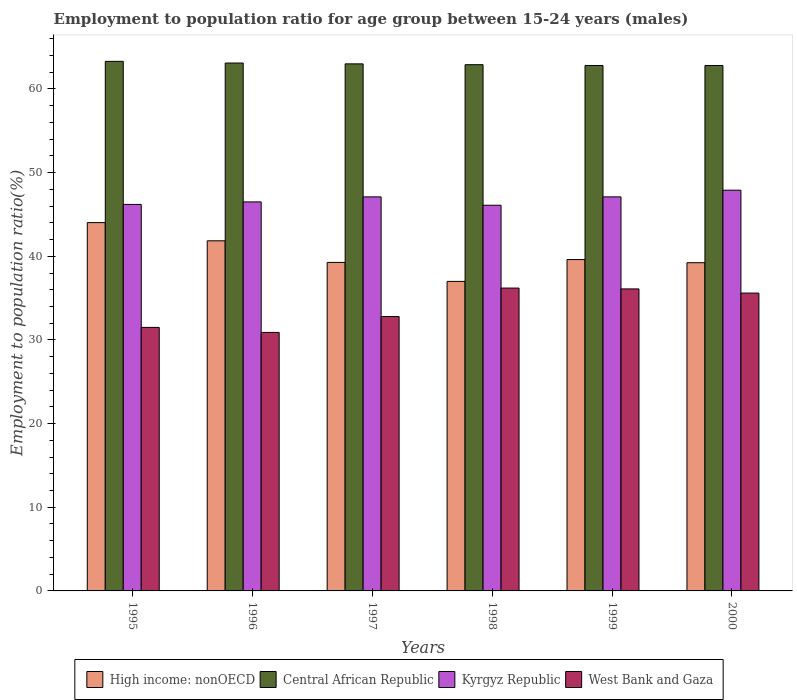Are the number of bars per tick equal to the number of legend labels?
Provide a succinct answer. Yes. What is the employment to population ratio in Central African Republic in 1996?
Keep it short and to the point. 63.1. Across all years, what is the maximum employment to population ratio in High income: nonOECD?
Make the answer very short. 44.03. Across all years, what is the minimum employment to population ratio in West Bank and Gaza?
Provide a succinct answer. 30.9. What is the total employment to population ratio in High income: nonOECD in the graph?
Make the answer very short. 240.98. What is the difference between the employment to population ratio in Kyrgyz Republic in 1995 and that in 1999?
Offer a terse response. -0.9. What is the difference between the employment to population ratio in Central African Republic in 2000 and the employment to population ratio in Kyrgyz Republic in 1995?
Make the answer very short. 16.6. What is the average employment to population ratio in West Bank and Gaza per year?
Your response must be concise. 33.85. In the year 1995, what is the difference between the employment to population ratio in High income: nonOECD and employment to population ratio in Central African Republic?
Ensure brevity in your answer.  -19.27. In how many years, is the employment to population ratio in Kyrgyz Republic greater than 38 %?
Keep it short and to the point. 6. What is the ratio of the employment to population ratio in Kyrgyz Republic in 1999 to that in 2000?
Provide a succinct answer. 0.98. Is the difference between the employment to population ratio in High income: nonOECD in 1996 and 2000 greater than the difference between the employment to population ratio in Central African Republic in 1996 and 2000?
Your response must be concise. Yes. What is the difference between the highest and the second highest employment to population ratio in Kyrgyz Republic?
Keep it short and to the point. 0.8. In how many years, is the employment to population ratio in West Bank and Gaza greater than the average employment to population ratio in West Bank and Gaza taken over all years?
Your answer should be compact. 3. What does the 1st bar from the left in 1996 represents?
Offer a terse response. High income: nonOECD. What does the 2nd bar from the right in 1998 represents?
Offer a terse response. Kyrgyz Republic. How many bars are there?
Your answer should be compact. 24. What is the difference between two consecutive major ticks on the Y-axis?
Keep it short and to the point. 10. Are the values on the major ticks of Y-axis written in scientific E-notation?
Offer a terse response. No. Does the graph contain any zero values?
Your response must be concise. No. Does the graph contain grids?
Keep it short and to the point. No. What is the title of the graph?
Give a very brief answer. Employment to population ratio for age group between 15-24 years (males). What is the label or title of the X-axis?
Make the answer very short. Years. What is the label or title of the Y-axis?
Offer a very short reply. Employment to population ratio(%). What is the Employment to population ratio(%) in High income: nonOECD in 1995?
Your answer should be compact. 44.03. What is the Employment to population ratio(%) of Central African Republic in 1995?
Offer a terse response. 63.3. What is the Employment to population ratio(%) in Kyrgyz Republic in 1995?
Keep it short and to the point. 46.2. What is the Employment to population ratio(%) in West Bank and Gaza in 1995?
Make the answer very short. 31.5. What is the Employment to population ratio(%) of High income: nonOECD in 1996?
Make the answer very short. 41.85. What is the Employment to population ratio(%) in Central African Republic in 1996?
Keep it short and to the point. 63.1. What is the Employment to population ratio(%) of Kyrgyz Republic in 1996?
Offer a very short reply. 46.5. What is the Employment to population ratio(%) in West Bank and Gaza in 1996?
Your answer should be compact. 30.9. What is the Employment to population ratio(%) of High income: nonOECD in 1997?
Give a very brief answer. 39.27. What is the Employment to population ratio(%) in Kyrgyz Republic in 1997?
Give a very brief answer. 47.1. What is the Employment to population ratio(%) of West Bank and Gaza in 1997?
Provide a short and direct response. 32.8. What is the Employment to population ratio(%) of High income: nonOECD in 1998?
Offer a very short reply. 37. What is the Employment to population ratio(%) of Central African Republic in 1998?
Give a very brief answer. 62.9. What is the Employment to population ratio(%) in Kyrgyz Republic in 1998?
Offer a very short reply. 46.1. What is the Employment to population ratio(%) in West Bank and Gaza in 1998?
Make the answer very short. 36.2. What is the Employment to population ratio(%) of High income: nonOECD in 1999?
Ensure brevity in your answer.  39.61. What is the Employment to population ratio(%) of Central African Republic in 1999?
Offer a terse response. 62.8. What is the Employment to population ratio(%) of Kyrgyz Republic in 1999?
Your response must be concise. 47.1. What is the Employment to population ratio(%) of West Bank and Gaza in 1999?
Give a very brief answer. 36.1. What is the Employment to population ratio(%) in High income: nonOECD in 2000?
Provide a short and direct response. 39.23. What is the Employment to population ratio(%) in Central African Republic in 2000?
Offer a terse response. 62.8. What is the Employment to population ratio(%) in Kyrgyz Republic in 2000?
Keep it short and to the point. 47.9. What is the Employment to population ratio(%) of West Bank and Gaza in 2000?
Keep it short and to the point. 35.6. Across all years, what is the maximum Employment to population ratio(%) in High income: nonOECD?
Offer a terse response. 44.03. Across all years, what is the maximum Employment to population ratio(%) in Central African Republic?
Offer a terse response. 63.3. Across all years, what is the maximum Employment to population ratio(%) of Kyrgyz Republic?
Offer a terse response. 47.9. Across all years, what is the maximum Employment to population ratio(%) of West Bank and Gaza?
Give a very brief answer. 36.2. Across all years, what is the minimum Employment to population ratio(%) in High income: nonOECD?
Provide a short and direct response. 37. Across all years, what is the minimum Employment to population ratio(%) in Central African Republic?
Keep it short and to the point. 62.8. Across all years, what is the minimum Employment to population ratio(%) of Kyrgyz Republic?
Keep it short and to the point. 46.1. Across all years, what is the minimum Employment to population ratio(%) in West Bank and Gaza?
Offer a terse response. 30.9. What is the total Employment to population ratio(%) of High income: nonOECD in the graph?
Offer a terse response. 240.98. What is the total Employment to population ratio(%) in Central African Republic in the graph?
Offer a very short reply. 377.9. What is the total Employment to population ratio(%) in Kyrgyz Republic in the graph?
Offer a terse response. 280.9. What is the total Employment to population ratio(%) of West Bank and Gaza in the graph?
Offer a terse response. 203.1. What is the difference between the Employment to population ratio(%) in High income: nonOECD in 1995 and that in 1996?
Provide a short and direct response. 2.17. What is the difference between the Employment to population ratio(%) in Kyrgyz Republic in 1995 and that in 1996?
Your answer should be very brief. -0.3. What is the difference between the Employment to population ratio(%) of High income: nonOECD in 1995 and that in 1997?
Your response must be concise. 4.76. What is the difference between the Employment to population ratio(%) of Central African Republic in 1995 and that in 1997?
Make the answer very short. 0.3. What is the difference between the Employment to population ratio(%) in Kyrgyz Republic in 1995 and that in 1997?
Provide a short and direct response. -0.9. What is the difference between the Employment to population ratio(%) in West Bank and Gaza in 1995 and that in 1997?
Offer a very short reply. -1.3. What is the difference between the Employment to population ratio(%) of High income: nonOECD in 1995 and that in 1998?
Your response must be concise. 7.03. What is the difference between the Employment to population ratio(%) in Central African Republic in 1995 and that in 1998?
Your answer should be very brief. 0.4. What is the difference between the Employment to population ratio(%) in Kyrgyz Republic in 1995 and that in 1998?
Offer a very short reply. 0.1. What is the difference between the Employment to population ratio(%) of West Bank and Gaza in 1995 and that in 1998?
Your response must be concise. -4.7. What is the difference between the Employment to population ratio(%) of High income: nonOECD in 1995 and that in 1999?
Your answer should be very brief. 4.42. What is the difference between the Employment to population ratio(%) of Central African Republic in 1995 and that in 1999?
Your response must be concise. 0.5. What is the difference between the Employment to population ratio(%) of High income: nonOECD in 1995 and that in 2000?
Offer a very short reply. 4.79. What is the difference between the Employment to population ratio(%) in Central African Republic in 1995 and that in 2000?
Keep it short and to the point. 0.5. What is the difference between the Employment to population ratio(%) in High income: nonOECD in 1996 and that in 1997?
Make the answer very short. 2.58. What is the difference between the Employment to population ratio(%) in West Bank and Gaza in 1996 and that in 1997?
Provide a short and direct response. -1.9. What is the difference between the Employment to population ratio(%) of High income: nonOECD in 1996 and that in 1998?
Provide a succinct answer. 4.85. What is the difference between the Employment to population ratio(%) in West Bank and Gaza in 1996 and that in 1998?
Keep it short and to the point. -5.3. What is the difference between the Employment to population ratio(%) of High income: nonOECD in 1996 and that in 1999?
Provide a succinct answer. 2.24. What is the difference between the Employment to population ratio(%) in Kyrgyz Republic in 1996 and that in 1999?
Give a very brief answer. -0.6. What is the difference between the Employment to population ratio(%) of High income: nonOECD in 1996 and that in 2000?
Your response must be concise. 2.62. What is the difference between the Employment to population ratio(%) in Central African Republic in 1996 and that in 2000?
Offer a terse response. 0.3. What is the difference between the Employment to population ratio(%) in West Bank and Gaza in 1996 and that in 2000?
Give a very brief answer. -4.7. What is the difference between the Employment to population ratio(%) of High income: nonOECD in 1997 and that in 1998?
Give a very brief answer. 2.27. What is the difference between the Employment to population ratio(%) in Central African Republic in 1997 and that in 1998?
Offer a terse response. 0.1. What is the difference between the Employment to population ratio(%) of West Bank and Gaza in 1997 and that in 1998?
Offer a terse response. -3.4. What is the difference between the Employment to population ratio(%) in High income: nonOECD in 1997 and that in 1999?
Offer a terse response. -0.34. What is the difference between the Employment to population ratio(%) in Kyrgyz Republic in 1997 and that in 1999?
Your response must be concise. 0. What is the difference between the Employment to population ratio(%) in High income: nonOECD in 1997 and that in 2000?
Provide a succinct answer. 0.04. What is the difference between the Employment to population ratio(%) in Central African Republic in 1997 and that in 2000?
Ensure brevity in your answer.  0.2. What is the difference between the Employment to population ratio(%) in High income: nonOECD in 1998 and that in 1999?
Keep it short and to the point. -2.61. What is the difference between the Employment to population ratio(%) in Central African Republic in 1998 and that in 1999?
Your response must be concise. 0.1. What is the difference between the Employment to population ratio(%) in Kyrgyz Republic in 1998 and that in 1999?
Ensure brevity in your answer.  -1. What is the difference between the Employment to population ratio(%) in West Bank and Gaza in 1998 and that in 1999?
Offer a terse response. 0.1. What is the difference between the Employment to population ratio(%) in High income: nonOECD in 1998 and that in 2000?
Ensure brevity in your answer.  -2.23. What is the difference between the Employment to population ratio(%) of Central African Republic in 1998 and that in 2000?
Offer a terse response. 0.1. What is the difference between the Employment to population ratio(%) in Kyrgyz Republic in 1998 and that in 2000?
Provide a succinct answer. -1.8. What is the difference between the Employment to population ratio(%) of High income: nonOECD in 1999 and that in 2000?
Ensure brevity in your answer.  0.38. What is the difference between the Employment to population ratio(%) of High income: nonOECD in 1995 and the Employment to population ratio(%) of Central African Republic in 1996?
Provide a short and direct response. -19.07. What is the difference between the Employment to population ratio(%) of High income: nonOECD in 1995 and the Employment to population ratio(%) of Kyrgyz Republic in 1996?
Offer a terse response. -2.47. What is the difference between the Employment to population ratio(%) of High income: nonOECD in 1995 and the Employment to population ratio(%) of West Bank and Gaza in 1996?
Make the answer very short. 13.13. What is the difference between the Employment to population ratio(%) in Central African Republic in 1995 and the Employment to population ratio(%) in West Bank and Gaza in 1996?
Give a very brief answer. 32.4. What is the difference between the Employment to population ratio(%) in High income: nonOECD in 1995 and the Employment to population ratio(%) in Central African Republic in 1997?
Keep it short and to the point. -18.97. What is the difference between the Employment to population ratio(%) in High income: nonOECD in 1995 and the Employment to population ratio(%) in Kyrgyz Republic in 1997?
Provide a short and direct response. -3.07. What is the difference between the Employment to population ratio(%) in High income: nonOECD in 1995 and the Employment to population ratio(%) in West Bank and Gaza in 1997?
Keep it short and to the point. 11.23. What is the difference between the Employment to population ratio(%) of Central African Republic in 1995 and the Employment to population ratio(%) of Kyrgyz Republic in 1997?
Your answer should be very brief. 16.2. What is the difference between the Employment to population ratio(%) of Central African Republic in 1995 and the Employment to population ratio(%) of West Bank and Gaza in 1997?
Offer a very short reply. 30.5. What is the difference between the Employment to population ratio(%) in High income: nonOECD in 1995 and the Employment to population ratio(%) in Central African Republic in 1998?
Give a very brief answer. -18.87. What is the difference between the Employment to population ratio(%) in High income: nonOECD in 1995 and the Employment to population ratio(%) in Kyrgyz Republic in 1998?
Your answer should be compact. -2.07. What is the difference between the Employment to population ratio(%) in High income: nonOECD in 1995 and the Employment to population ratio(%) in West Bank and Gaza in 1998?
Ensure brevity in your answer.  7.83. What is the difference between the Employment to population ratio(%) of Central African Republic in 1995 and the Employment to population ratio(%) of West Bank and Gaza in 1998?
Your response must be concise. 27.1. What is the difference between the Employment to population ratio(%) of Kyrgyz Republic in 1995 and the Employment to population ratio(%) of West Bank and Gaza in 1998?
Give a very brief answer. 10. What is the difference between the Employment to population ratio(%) in High income: nonOECD in 1995 and the Employment to population ratio(%) in Central African Republic in 1999?
Your response must be concise. -18.77. What is the difference between the Employment to population ratio(%) of High income: nonOECD in 1995 and the Employment to population ratio(%) of Kyrgyz Republic in 1999?
Provide a succinct answer. -3.07. What is the difference between the Employment to population ratio(%) in High income: nonOECD in 1995 and the Employment to population ratio(%) in West Bank and Gaza in 1999?
Offer a terse response. 7.93. What is the difference between the Employment to population ratio(%) in Central African Republic in 1995 and the Employment to population ratio(%) in Kyrgyz Republic in 1999?
Give a very brief answer. 16.2. What is the difference between the Employment to population ratio(%) of Central African Republic in 1995 and the Employment to population ratio(%) of West Bank and Gaza in 1999?
Give a very brief answer. 27.2. What is the difference between the Employment to population ratio(%) in Kyrgyz Republic in 1995 and the Employment to population ratio(%) in West Bank and Gaza in 1999?
Make the answer very short. 10.1. What is the difference between the Employment to population ratio(%) of High income: nonOECD in 1995 and the Employment to population ratio(%) of Central African Republic in 2000?
Your answer should be very brief. -18.77. What is the difference between the Employment to population ratio(%) of High income: nonOECD in 1995 and the Employment to population ratio(%) of Kyrgyz Republic in 2000?
Your response must be concise. -3.87. What is the difference between the Employment to population ratio(%) of High income: nonOECD in 1995 and the Employment to population ratio(%) of West Bank and Gaza in 2000?
Your answer should be very brief. 8.43. What is the difference between the Employment to population ratio(%) of Central African Republic in 1995 and the Employment to population ratio(%) of Kyrgyz Republic in 2000?
Your answer should be compact. 15.4. What is the difference between the Employment to population ratio(%) of Central African Republic in 1995 and the Employment to population ratio(%) of West Bank and Gaza in 2000?
Provide a short and direct response. 27.7. What is the difference between the Employment to population ratio(%) of High income: nonOECD in 1996 and the Employment to population ratio(%) of Central African Republic in 1997?
Your answer should be very brief. -21.15. What is the difference between the Employment to population ratio(%) in High income: nonOECD in 1996 and the Employment to population ratio(%) in Kyrgyz Republic in 1997?
Your answer should be very brief. -5.25. What is the difference between the Employment to population ratio(%) in High income: nonOECD in 1996 and the Employment to population ratio(%) in West Bank and Gaza in 1997?
Offer a terse response. 9.05. What is the difference between the Employment to population ratio(%) of Central African Republic in 1996 and the Employment to population ratio(%) of West Bank and Gaza in 1997?
Ensure brevity in your answer.  30.3. What is the difference between the Employment to population ratio(%) in High income: nonOECD in 1996 and the Employment to population ratio(%) in Central African Republic in 1998?
Provide a succinct answer. -21.05. What is the difference between the Employment to population ratio(%) in High income: nonOECD in 1996 and the Employment to population ratio(%) in Kyrgyz Republic in 1998?
Offer a terse response. -4.25. What is the difference between the Employment to population ratio(%) in High income: nonOECD in 1996 and the Employment to population ratio(%) in West Bank and Gaza in 1998?
Offer a terse response. 5.65. What is the difference between the Employment to population ratio(%) of Central African Republic in 1996 and the Employment to population ratio(%) of Kyrgyz Republic in 1998?
Provide a short and direct response. 17. What is the difference between the Employment to population ratio(%) of Central African Republic in 1996 and the Employment to population ratio(%) of West Bank and Gaza in 1998?
Keep it short and to the point. 26.9. What is the difference between the Employment to population ratio(%) of Kyrgyz Republic in 1996 and the Employment to population ratio(%) of West Bank and Gaza in 1998?
Your answer should be compact. 10.3. What is the difference between the Employment to population ratio(%) of High income: nonOECD in 1996 and the Employment to population ratio(%) of Central African Republic in 1999?
Your answer should be compact. -20.95. What is the difference between the Employment to population ratio(%) in High income: nonOECD in 1996 and the Employment to population ratio(%) in Kyrgyz Republic in 1999?
Offer a very short reply. -5.25. What is the difference between the Employment to population ratio(%) of High income: nonOECD in 1996 and the Employment to population ratio(%) of West Bank and Gaza in 1999?
Provide a succinct answer. 5.75. What is the difference between the Employment to population ratio(%) of Kyrgyz Republic in 1996 and the Employment to population ratio(%) of West Bank and Gaza in 1999?
Offer a terse response. 10.4. What is the difference between the Employment to population ratio(%) in High income: nonOECD in 1996 and the Employment to population ratio(%) in Central African Republic in 2000?
Your response must be concise. -20.95. What is the difference between the Employment to population ratio(%) in High income: nonOECD in 1996 and the Employment to population ratio(%) in Kyrgyz Republic in 2000?
Your answer should be compact. -6.05. What is the difference between the Employment to population ratio(%) of High income: nonOECD in 1996 and the Employment to population ratio(%) of West Bank and Gaza in 2000?
Your answer should be very brief. 6.25. What is the difference between the Employment to population ratio(%) of Central African Republic in 1996 and the Employment to population ratio(%) of West Bank and Gaza in 2000?
Offer a terse response. 27.5. What is the difference between the Employment to population ratio(%) of High income: nonOECD in 1997 and the Employment to population ratio(%) of Central African Republic in 1998?
Make the answer very short. -23.63. What is the difference between the Employment to population ratio(%) of High income: nonOECD in 1997 and the Employment to population ratio(%) of Kyrgyz Republic in 1998?
Give a very brief answer. -6.83. What is the difference between the Employment to population ratio(%) of High income: nonOECD in 1997 and the Employment to population ratio(%) of West Bank and Gaza in 1998?
Offer a very short reply. 3.07. What is the difference between the Employment to population ratio(%) in Central African Republic in 1997 and the Employment to population ratio(%) in West Bank and Gaza in 1998?
Provide a succinct answer. 26.8. What is the difference between the Employment to population ratio(%) in High income: nonOECD in 1997 and the Employment to population ratio(%) in Central African Republic in 1999?
Your answer should be compact. -23.53. What is the difference between the Employment to population ratio(%) of High income: nonOECD in 1997 and the Employment to population ratio(%) of Kyrgyz Republic in 1999?
Your response must be concise. -7.83. What is the difference between the Employment to population ratio(%) in High income: nonOECD in 1997 and the Employment to population ratio(%) in West Bank and Gaza in 1999?
Make the answer very short. 3.17. What is the difference between the Employment to population ratio(%) of Central African Republic in 1997 and the Employment to population ratio(%) of West Bank and Gaza in 1999?
Your answer should be very brief. 26.9. What is the difference between the Employment to population ratio(%) of High income: nonOECD in 1997 and the Employment to population ratio(%) of Central African Republic in 2000?
Your answer should be very brief. -23.53. What is the difference between the Employment to population ratio(%) in High income: nonOECD in 1997 and the Employment to population ratio(%) in Kyrgyz Republic in 2000?
Give a very brief answer. -8.63. What is the difference between the Employment to population ratio(%) in High income: nonOECD in 1997 and the Employment to population ratio(%) in West Bank and Gaza in 2000?
Provide a short and direct response. 3.67. What is the difference between the Employment to population ratio(%) in Central African Republic in 1997 and the Employment to population ratio(%) in West Bank and Gaza in 2000?
Offer a very short reply. 27.4. What is the difference between the Employment to population ratio(%) of Kyrgyz Republic in 1997 and the Employment to population ratio(%) of West Bank and Gaza in 2000?
Provide a short and direct response. 11.5. What is the difference between the Employment to population ratio(%) in High income: nonOECD in 1998 and the Employment to population ratio(%) in Central African Republic in 1999?
Keep it short and to the point. -25.8. What is the difference between the Employment to population ratio(%) of High income: nonOECD in 1998 and the Employment to population ratio(%) of Kyrgyz Republic in 1999?
Make the answer very short. -10.1. What is the difference between the Employment to population ratio(%) in High income: nonOECD in 1998 and the Employment to population ratio(%) in West Bank and Gaza in 1999?
Provide a short and direct response. 0.9. What is the difference between the Employment to population ratio(%) of Central African Republic in 1998 and the Employment to population ratio(%) of Kyrgyz Republic in 1999?
Offer a very short reply. 15.8. What is the difference between the Employment to population ratio(%) in Central African Republic in 1998 and the Employment to population ratio(%) in West Bank and Gaza in 1999?
Offer a very short reply. 26.8. What is the difference between the Employment to population ratio(%) of Kyrgyz Republic in 1998 and the Employment to population ratio(%) of West Bank and Gaza in 1999?
Provide a succinct answer. 10. What is the difference between the Employment to population ratio(%) of High income: nonOECD in 1998 and the Employment to population ratio(%) of Central African Republic in 2000?
Give a very brief answer. -25.8. What is the difference between the Employment to population ratio(%) of High income: nonOECD in 1998 and the Employment to population ratio(%) of Kyrgyz Republic in 2000?
Provide a short and direct response. -10.9. What is the difference between the Employment to population ratio(%) of High income: nonOECD in 1998 and the Employment to population ratio(%) of West Bank and Gaza in 2000?
Offer a very short reply. 1.4. What is the difference between the Employment to population ratio(%) in Central African Republic in 1998 and the Employment to population ratio(%) in West Bank and Gaza in 2000?
Ensure brevity in your answer.  27.3. What is the difference between the Employment to population ratio(%) of Kyrgyz Republic in 1998 and the Employment to population ratio(%) of West Bank and Gaza in 2000?
Your answer should be very brief. 10.5. What is the difference between the Employment to population ratio(%) in High income: nonOECD in 1999 and the Employment to population ratio(%) in Central African Republic in 2000?
Give a very brief answer. -23.19. What is the difference between the Employment to population ratio(%) in High income: nonOECD in 1999 and the Employment to population ratio(%) in Kyrgyz Republic in 2000?
Offer a very short reply. -8.29. What is the difference between the Employment to population ratio(%) in High income: nonOECD in 1999 and the Employment to population ratio(%) in West Bank and Gaza in 2000?
Offer a very short reply. 4.01. What is the difference between the Employment to population ratio(%) in Central African Republic in 1999 and the Employment to population ratio(%) in West Bank and Gaza in 2000?
Offer a very short reply. 27.2. What is the average Employment to population ratio(%) in High income: nonOECD per year?
Ensure brevity in your answer.  40.16. What is the average Employment to population ratio(%) of Central African Republic per year?
Give a very brief answer. 62.98. What is the average Employment to population ratio(%) of Kyrgyz Republic per year?
Provide a short and direct response. 46.82. What is the average Employment to population ratio(%) in West Bank and Gaza per year?
Give a very brief answer. 33.85. In the year 1995, what is the difference between the Employment to population ratio(%) in High income: nonOECD and Employment to population ratio(%) in Central African Republic?
Give a very brief answer. -19.27. In the year 1995, what is the difference between the Employment to population ratio(%) of High income: nonOECD and Employment to population ratio(%) of Kyrgyz Republic?
Provide a succinct answer. -2.17. In the year 1995, what is the difference between the Employment to population ratio(%) in High income: nonOECD and Employment to population ratio(%) in West Bank and Gaza?
Offer a very short reply. 12.53. In the year 1995, what is the difference between the Employment to population ratio(%) of Central African Republic and Employment to population ratio(%) of West Bank and Gaza?
Your answer should be compact. 31.8. In the year 1996, what is the difference between the Employment to population ratio(%) of High income: nonOECD and Employment to population ratio(%) of Central African Republic?
Make the answer very short. -21.25. In the year 1996, what is the difference between the Employment to population ratio(%) of High income: nonOECD and Employment to population ratio(%) of Kyrgyz Republic?
Your response must be concise. -4.65. In the year 1996, what is the difference between the Employment to population ratio(%) in High income: nonOECD and Employment to population ratio(%) in West Bank and Gaza?
Provide a succinct answer. 10.95. In the year 1996, what is the difference between the Employment to population ratio(%) in Central African Republic and Employment to population ratio(%) in West Bank and Gaza?
Give a very brief answer. 32.2. In the year 1997, what is the difference between the Employment to population ratio(%) in High income: nonOECD and Employment to population ratio(%) in Central African Republic?
Your answer should be very brief. -23.73. In the year 1997, what is the difference between the Employment to population ratio(%) in High income: nonOECD and Employment to population ratio(%) in Kyrgyz Republic?
Your response must be concise. -7.83. In the year 1997, what is the difference between the Employment to population ratio(%) in High income: nonOECD and Employment to population ratio(%) in West Bank and Gaza?
Offer a terse response. 6.47. In the year 1997, what is the difference between the Employment to population ratio(%) in Central African Republic and Employment to population ratio(%) in Kyrgyz Republic?
Provide a short and direct response. 15.9. In the year 1997, what is the difference between the Employment to population ratio(%) of Central African Republic and Employment to population ratio(%) of West Bank and Gaza?
Provide a short and direct response. 30.2. In the year 1998, what is the difference between the Employment to population ratio(%) of High income: nonOECD and Employment to population ratio(%) of Central African Republic?
Keep it short and to the point. -25.9. In the year 1998, what is the difference between the Employment to population ratio(%) in High income: nonOECD and Employment to population ratio(%) in Kyrgyz Republic?
Provide a short and direct response. -9.1. In the year 1998, what is the difference between the Employment to population ratio(%) of High income: nonOECD and Employment to population ratio(%) of West Bank and Gaza?
Your answer should be very brief. 0.8. In the year 1998, what is the difference between the Employment to population ratio(%) in Central African Republic and Employment to population ratio(%) in West Bank and Gaza?
Your response must be concise. 26.7. In the year 1998, what is the difference between the Employment to population ratio(%) of Kyrgyz Republic and Employment to population ratio(%) of West Bank and Gaza?
Give a very brief answer. 9.9. In the year 1999, what is the difference between the Employment to population ratio(%) of High income: nonOECD and Employment to population ratio(%) of Central African Republic?
Your answer should be very brief. -23.19. In the year 1999, what is the difference between the Employment to population ratio(%) of High income: nonOECD and Employment to population ratio(%) of Kyrgyz Republic?
Offer a terse response. -7.49. In the year 1999, what is the difference between the Employment to population ratio(%) of High income: nonOECD and Employment to population ratio(%) of West Bank and Gaza?
Give a very brief answer. 3.51. In the year 1999, what is the difference between the Employment to population ratio(%) in Central African Republic and Employment to population ratio(%) in Kyrgyz Republic?
Your response must be concise. 15.7. In the year 1999, what is the difference between the Employment to population ratio(%) in Central African Republic and Employment to population ratio(%) in West Bank and Gaza?
Your response must be concise. 26.7. In the year 2000, what is the difference between the Employment to population ratio(%) of High income: nonOECD and Employment to population ratio(%) of Central African Republic?
Give a very brief answer. -23.57. In the year 2000, what is the difference between the Employment to population ratio(%) of High income: nonOECD and Employment to population ratio(%) of Kyrgyz Republic?
Provide a short and direct response. -8.67. In the year 2000, what is the difference between the Employment to population ratio(%) in High income: nonOECD and Employment to population ratio(%) in West Bank and Gaza?
Your answer should be very brief. 3.63. In the year 2000, what is the difference between the Employment to population ratio(%) in Central African Republic and Employment to population ratio(%) in West Bank and Gaza?
Give a very brief answer. 27.2. What is the ratio of the Employment to population ratio(%) in High income: nonOECD in 1995 to that in 1996?
Provide a succinct answer. 1.05. What is the ratio of the Employment to population ratio(%) of Kyrgyz Republic in 1995 to that in 1996?
Provide a short and direct response. 0.99. What is the ratio of the Employment to population ratio(%) in West Bank and Gaza in 1995 to that in 1996?
Your answer should be compact. 1.02. What is the ratio of the Employment to population ratio(%) in High income: nonOECD in 1995 to that in 1997?
Offer a terse response. 1.12. What is the ratio of the Employment to population ratio(%) of Central African Republic in 1995 to that in 1997?
Keep it short and to the point. 1. What is the ratio of the Employment to population ratio(%) in Kyrgyz Republic in 1995 to that in 1997?
Your answer should be very brief. 0.98. What is the ratio of the Employment to population ratio(%) of West Bank and Gaza in 1995 to that in 1997?
Your response must be concise. 0.96. What is the ratio of the Employment to population ratio(%) in High income: nonOECD in 1995 to that in 1998?
Provide a succinct answer. 1.19. What is the ratio of the Employment to population ratio(%) of Central African Republic in 1995 to that in 1998?
Provide a succinct answer. 1.01. What is the ratio of the Employment to population ratio(%) of Kyrgyz Republic in 1995 to that in 1998?
Your answer should be compact. 1. What is the ratio of the Employment to population ratio(%) in West Bank and Gaza in 1995 to that in 1998?
Make the answer very short. 0.87. What is the ratio of the Employment to population ratio(%) in High income: nonOECD in 1995 to that in 1999?
Keep it short and to the point. 1.11. What is the ratio of the Employment to population ratio(%) of Kyrgyz Republic in 1995 to that in 1999?
Offer a very short reply. 0.98. What is the ratio of the Employment to population ratio(%) in West Bank and Gaza in 1995 to that in 1999?
Your answer should be compact. 0.87. What is the ratio of the Employment to population ratio(%) in High income: nonOECD in 1995 to that in 2000?
Ensure brevity in your answer.  1.12. What is the ratio of the Employment to population ratio(%) of Central African Republic in 1995 to that in 2000?
Ensure brevity in your answer.  1.01. What is the ratio of the Employment to population ratio(%) of Kyrgyz Republic in 1995 to that in 2000?
Make the answer very short. 0.96. What is the ratio of the Employment to population ratio(%) of West Bank and Gaza in 1995 to that in 2000?
Give a very brief answer. 0.88. What is the ratio of the Employment to population ratio(%) in High income: nonOECD in 1996 to that in 1997?
Make the answer very short. 1.07. What is the ratio of the Employment to population ratio(%) in Kyrgyz Republic in 1996 to that in 1997?
Offer a terse response. 0.99. What is the ratio of the Employment to population ratio(%) of West Bank and Gaza in 1996 to that in 1997?
Give a very brief answer. 0.94. What is the ratio of the Employment to population ratio(%) of High income: nonOECD in 1996 to that in 1998?
Your response must be concise. 1.13. What is the ratio of the Employment to population ratio(%) of Kyrgyz Republic in 1996 to that in 1998?
Your answer should be very brief. 1.01. What is the ratio of the Employment to population ratio(%) of West Bank and Gaza in 1996 to that in 1998?
Your response must be concise. 0.85. What is the ratio of the Employment to population ratio(%) in High income: nonOECD in 1996 to that in 1999?
Your answer should be very brief. 1.06. What is the ratio of the Employment to population ratio(%) in Kyrgyz Republic in 1996 to that in 1999?
Your response must be concise. 0.99. What is the ratio of the Employment to population ratio(%) in West Bank and Gaza in 1996 to that in 1999?
Your response must be concise. 0.86. What is the ratio of the Employment to population ratio(%) in High income: nonOECD in 1996 to that in 2000?
Offer a very short reply. 1.07. What is the ratio of the Employment to population ratio(%) of Central African Republic in 1996 to that in 2000?
Provide a short and direct response. 1. What is the ratio of the Employment to population ratio(%) of Kyrgyz Republic in 1996 to that in 2000?
Offer a very short reply. 0.97. What is the ratio of the Employment to population ratio(%) in West Bank and Gaza in 1996 to that in 2000?
Ensure brevity in your answer.  0.87. What is the ratio of the Employment to population ratio(%) in High income: nonOECD in 1997 to that in 1998?
Give a very brief answer. 1.06. What is the ratio of the Employment to population ratio(%) in Central African Republic in 1997 to that in 1998?
Offer a terse response. 1. What is the ratio of the Employment to population ratio(%) in Kyrgyz Republic in 1997 to that in 1998?
Provide a short and direct response. 1.02. What is the ratio of the Employment to population ratio(%) of West Bank and Gaza in 1997 to that in 1998?
Give a very brief answer. 0.91. What is the ratio of the Employment to population ratio(%) of High income: nonOECD in 1997 to that in 1999?
Give a very brief answer. 0.99. What is the ratio of the Employment to population ratio(%) in West Bank and Gaza in 1997 to that in 1999?
Offer a terse response. 0.91. What is the ratio of the Employment to population ratio(%) in High income: nonOECD in 1997 to that in 2000?
Your answer should be compact. 1. What is the ratio of the Employment to population ratio(%) of Kyrgyz Republic in 1997 to that in 2000?
Keep it short and to the point. 0.98. What is the ratio of the Employment to population ratio(%) in West Bank and Gaza in 1997 to that in 2000?
Your answer should be very brief. 0.92. What is the ratio of the Employment to population ratio(%) of High income: nonOECD in 1998 to that in 1999?
Your response must be concise. 0.93. What is the ratio of the Employment to population ratio(%) in Central African Republic in 1998 to that in 1999?
Provide a short and direct response. 1. What is the ratio of the Employment to population ratio(%) of Kyrgyz Republic in 1998 to that in 1999?
Offer a terse response. 0.98. What is the ratio of the Employment to population ratio(%) in High income: nonOECD in 1998 to that in 2000?
Give a very brief answer. 0.94. What is the ratio of the Employment to population ratio(%) in Central African Republic in 1998 to that in 2000?
Your answer should be compact. 1. What is the ratio of the Employment to population ratio(%) of Kyrgyz Republic in 1998 to that in 2000?
Keep it short and to the point. 0.96. What is the ratio of the Employment to population ratio(%) of West Bank and Gaza in 1998 to that in 2000?
Provide a short and direct response. 1.02. What is the ratio of the Employment to population ratio(%) in High income: nonOECD in 1999 to that in 2000?
Offer a very short reply. 1.01. What is the ratio of the Employment to population ratio(%) in Central African Republic in 1999 to that in 2000?
Provide a succinct answer. 1. What is the ratio of the Employment to population ratio(%) of Kyrgyz Republic in 1999 to that in 2000?
Make the answer very short. 0.98. What is the ratio of the Employment to population ratio(%) of West Bank and Gaza in 1999 to that in 2000?
Your answer should be compact. 1.01. What is the difference between the highest and the second highest Employment to population ratio(%) of High income: nonOECD?
Provide a short and direct response. 2.17. What is the difference between the highest and the second highest Employment to population ratio(%) in Central African Republic?
Keep it short and to the point. 0.2. What is the difference between the highest and the lowest Employment to population ratio(%) of High income: nonOECD?
Your answer should be compact. 7.03. What is the difference between the highest and the lowest Employment to population ratio(%) in Kyrgyz Republic?
Provide a succinct answer. 1.8. What is the difference between the highest and the lowest Employment to population ratio(%) in West Bank and Gaza?
Your response must be concise. 5.3. 